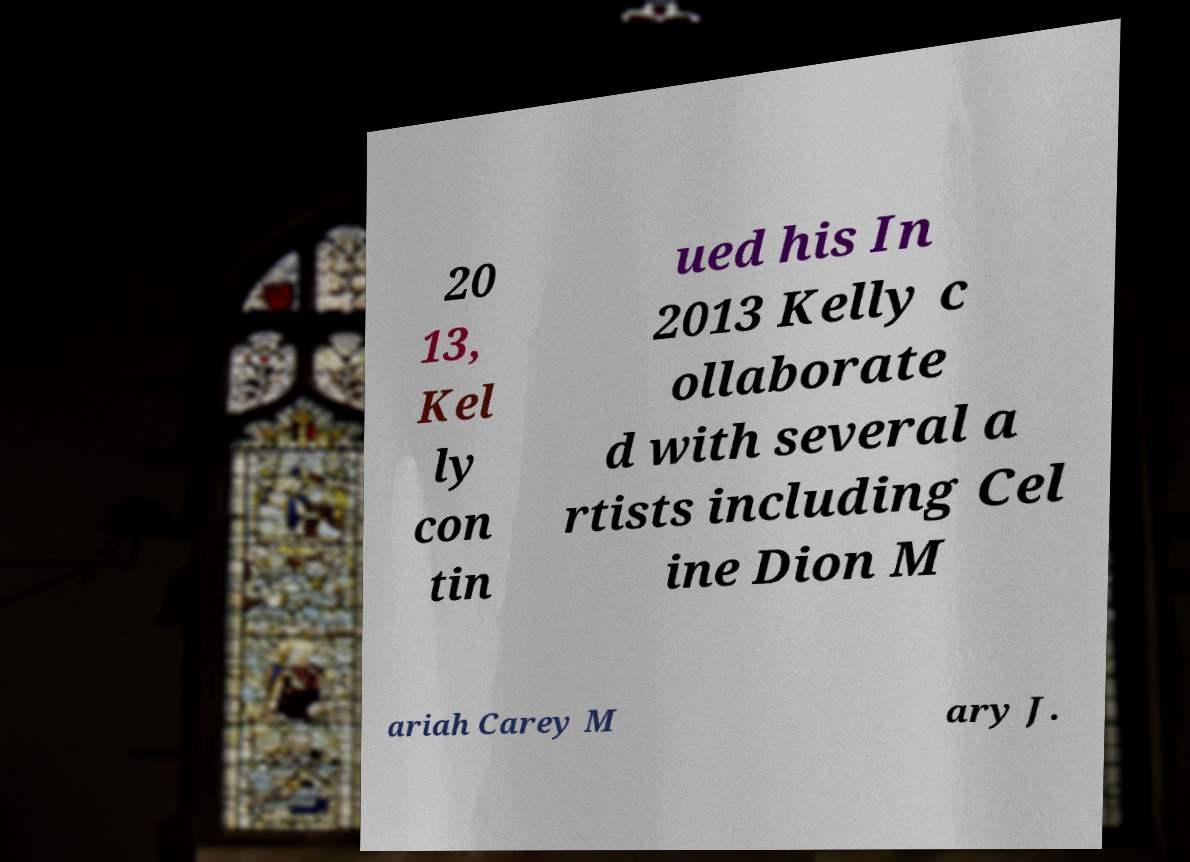What messages or text are displayed in this image? I need them in a readable, typed format. 20 13, Kel ly con tin ued his In 2013 Kelly c ollaborate d with several a rtists including Cel ine Dion M ariah Carey M ary J. 